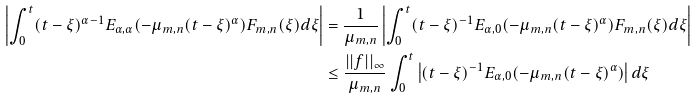<formula> <loc_0><loc_0><loc_500><loc_500>\left | \int _ { 0 } ^ { t } ( t - \xi ) ^ { \alpha - 1 } E _ { \alpha , \alpha } ( - \mu _ { m , n } ( t - \xi ) ^ { \alpha } ) F _ { m , n } ( \xi ) d \xi \right | & = \frac { 1 } { \mu _ { m , n } } \left | \int _ { 0 } ^ { t } ( t - \xi ) ^ { - 1 } E _ { \alpha , 0 } ( - \mu _ { m , n } ( t - \xi ) ^ { \alpha } ) F _ { m , n } ( \xi ) d \xi \right | \\ & \leq \frac { | | f | | _ { \infty } } { \mu _ { m , n } } \int _ { 0 } ^ { t } \left | ( t - \xi ) ^ { - 1 } E _ { \alpha , 0 } ( - \mu _ { m , n } ( t - \xi ) ^ { \alpha } ) \right | d \xi</formula> 